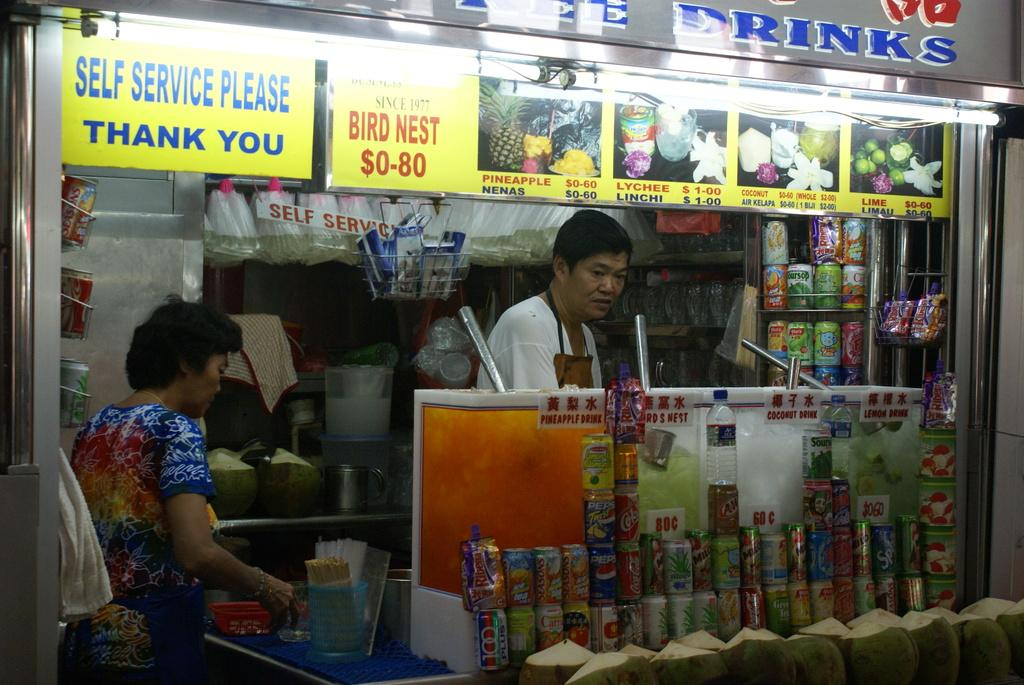<image>
Offer a succinct explanation of the picture presented. A sign at a food kiosk say you are to self service. 